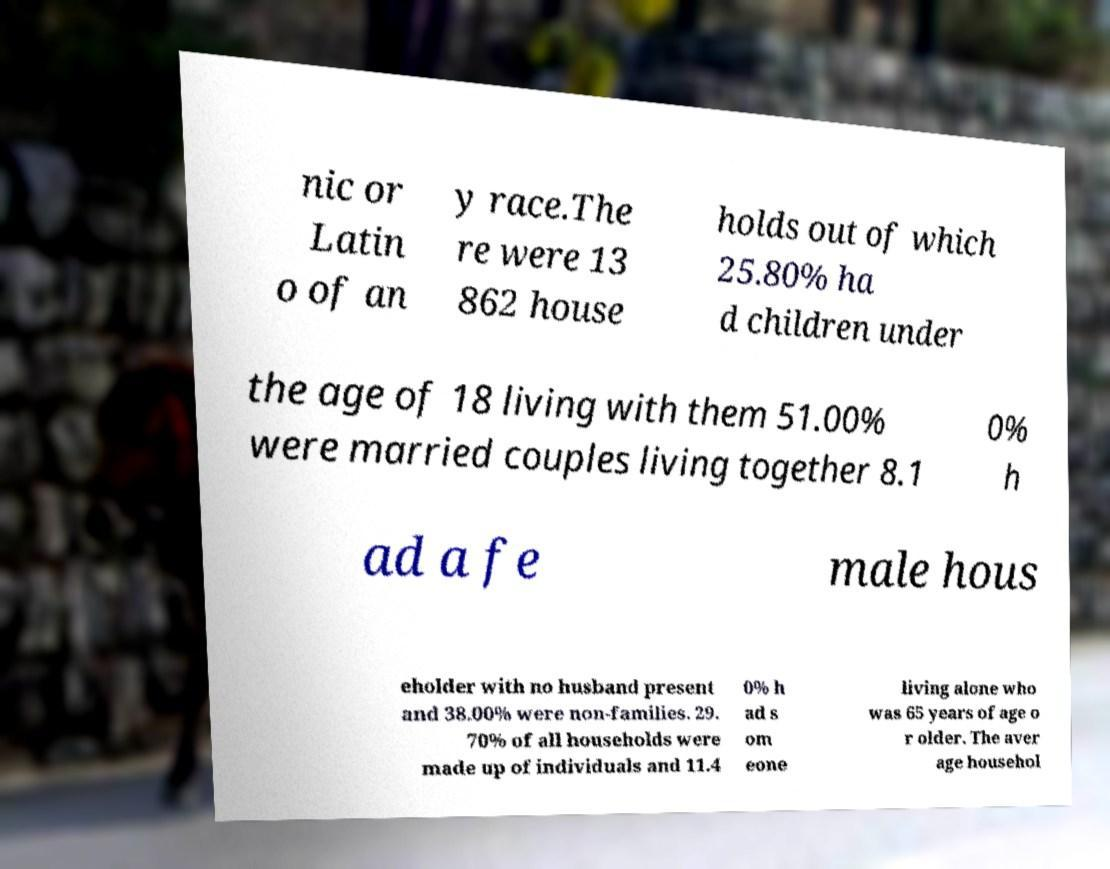For documentation purposes, I need the text within this image transcribed. Could you provide that? nic or Latin o of an y race.The re were 13 862 house holds out of which 25.80% ha d children under the age of 18 living with them 51.00% were married couples living together 8.1 0% h ad a fe male hous eholder with no husband present and 38.00% were non-families. 29. 70% of all households were made up of individuals and 11.4 0% h ad s om eone living alone who was 65 years of age o r older. The aver age househol 